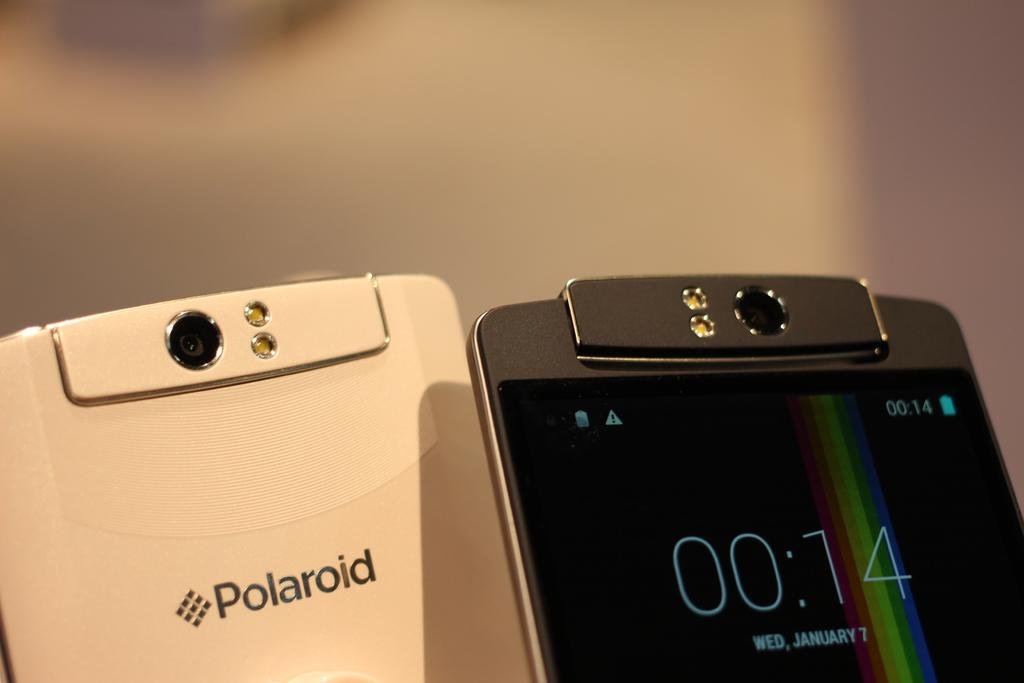<image>
Give a short and clear explanation of the subsequent image. Two Polaroid phones displayed next to each other 